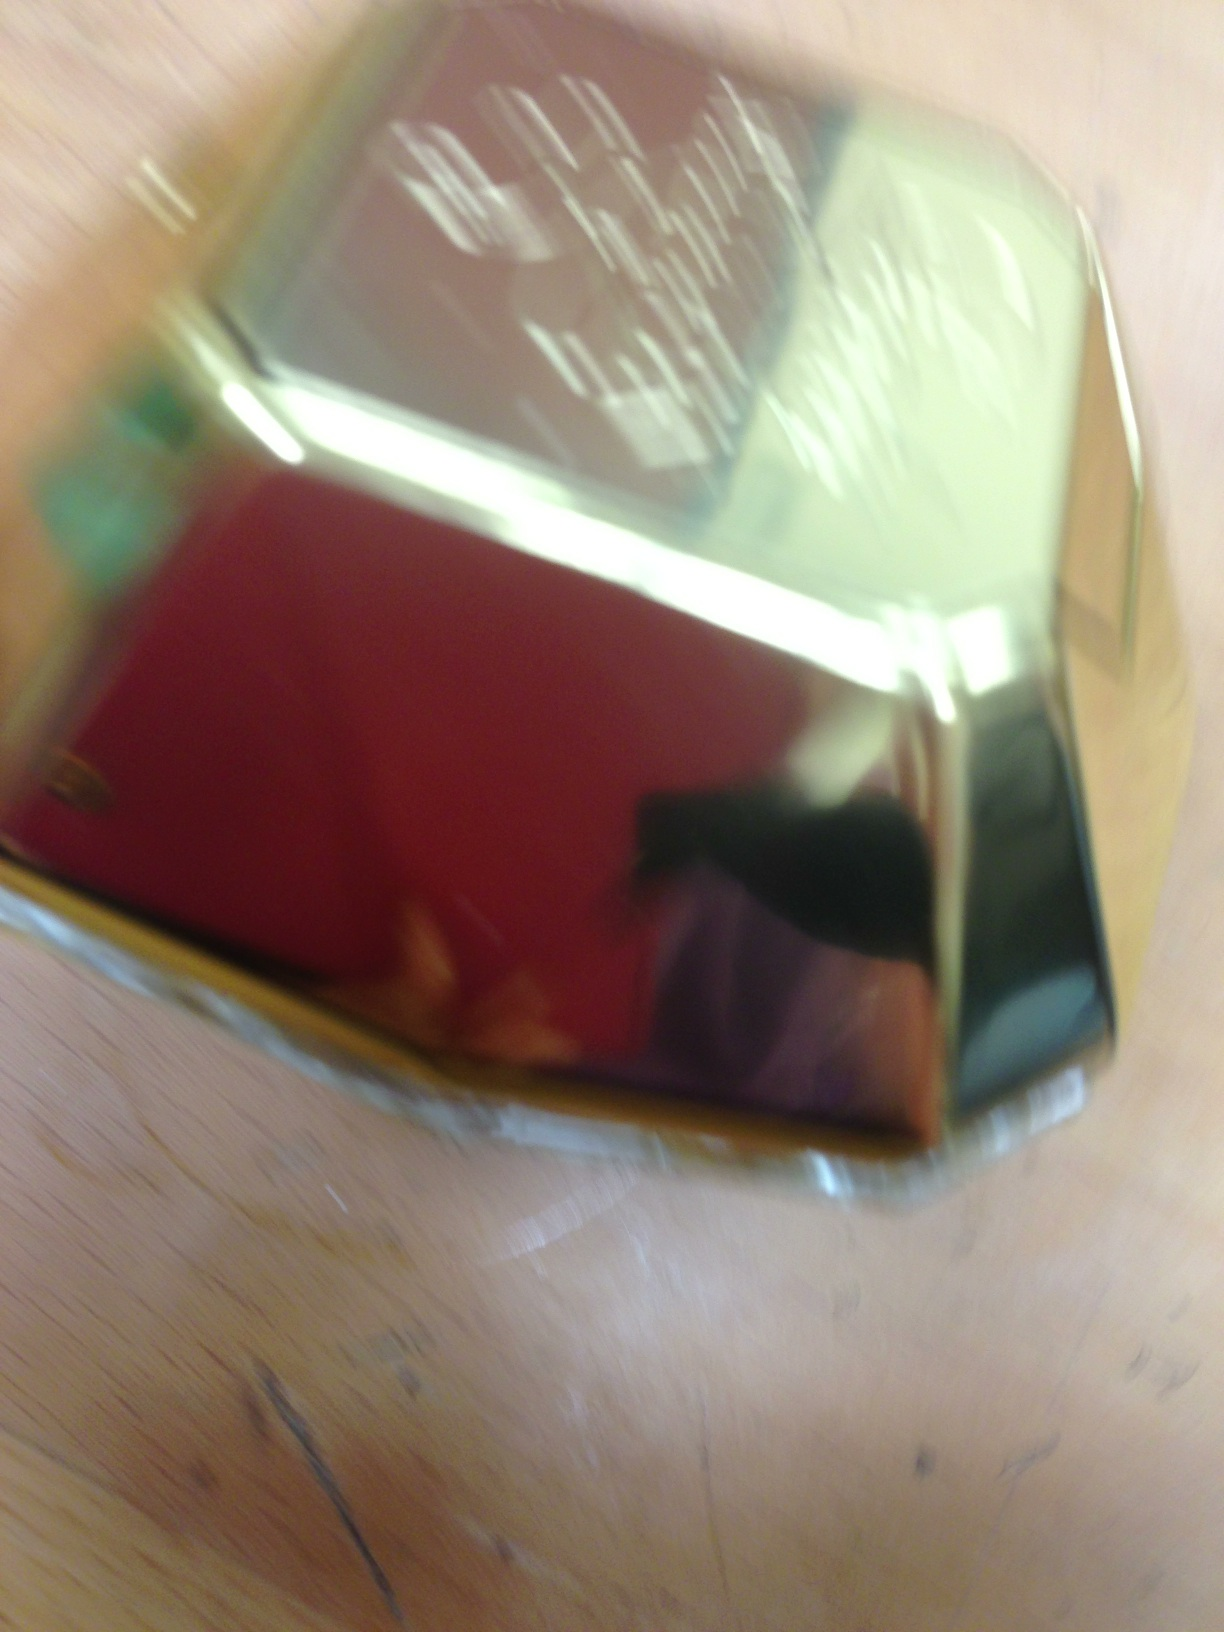Can you describe the design of this perfume bottle? From what can be seen, the perfume bottle seems to have a unique, geometric shape with metallic colors suggesting a luxurious and sophisticated design. However, the image is quite blurry, so I can't provide more specific details. 